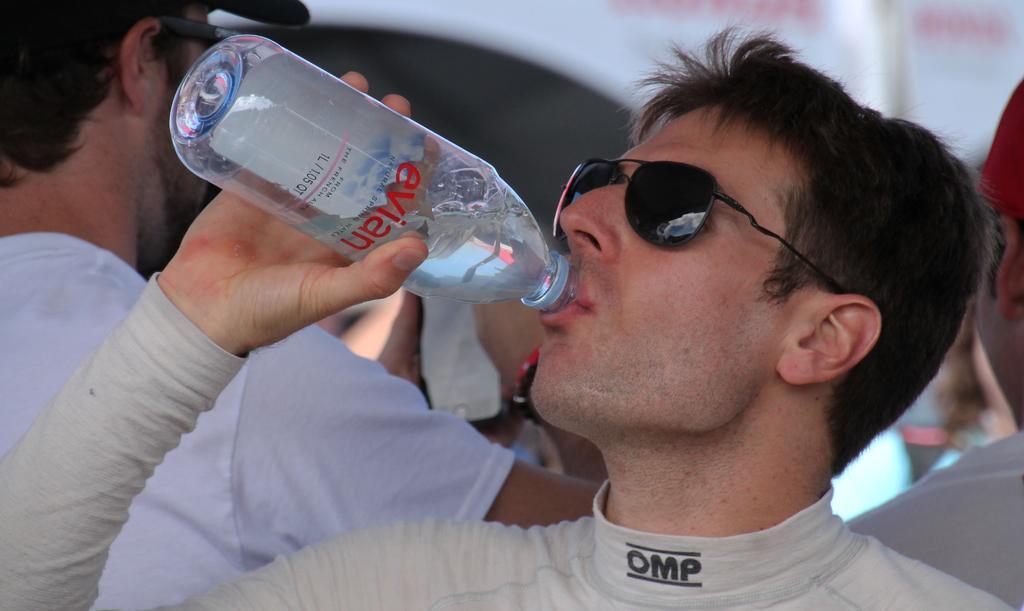How would you summarize this image in a sentence or two? This person wore goggles and drinking water from this bottle. This person is standing and wore cap. 